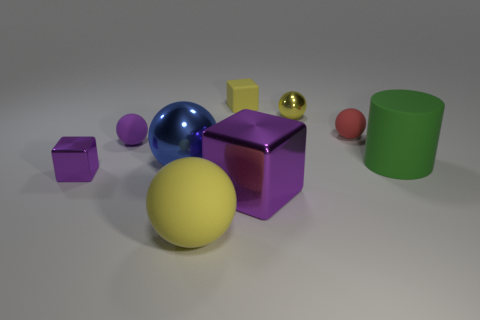Subtract all purple spheres. How many spheres are left? 4 Subtract all shiny balls. How many balls are left? 3 Add 1 big shiny objects. How many objects exist? 10 Subtract all green spheres. Subtract all purple cubes. How many spheres are left? 5 Subtract all cylinders. How many objects are left? 8 Add 6 large matte cylinders. How many large matte cylinders are left? 7 Add 2 small blue balls. How many small blue balls exist? 2 Subtract 0 cyan cubes. How many objects are left? 9 Subtract all big blocks. Subtract all small cubes. How many objects are left? 6 